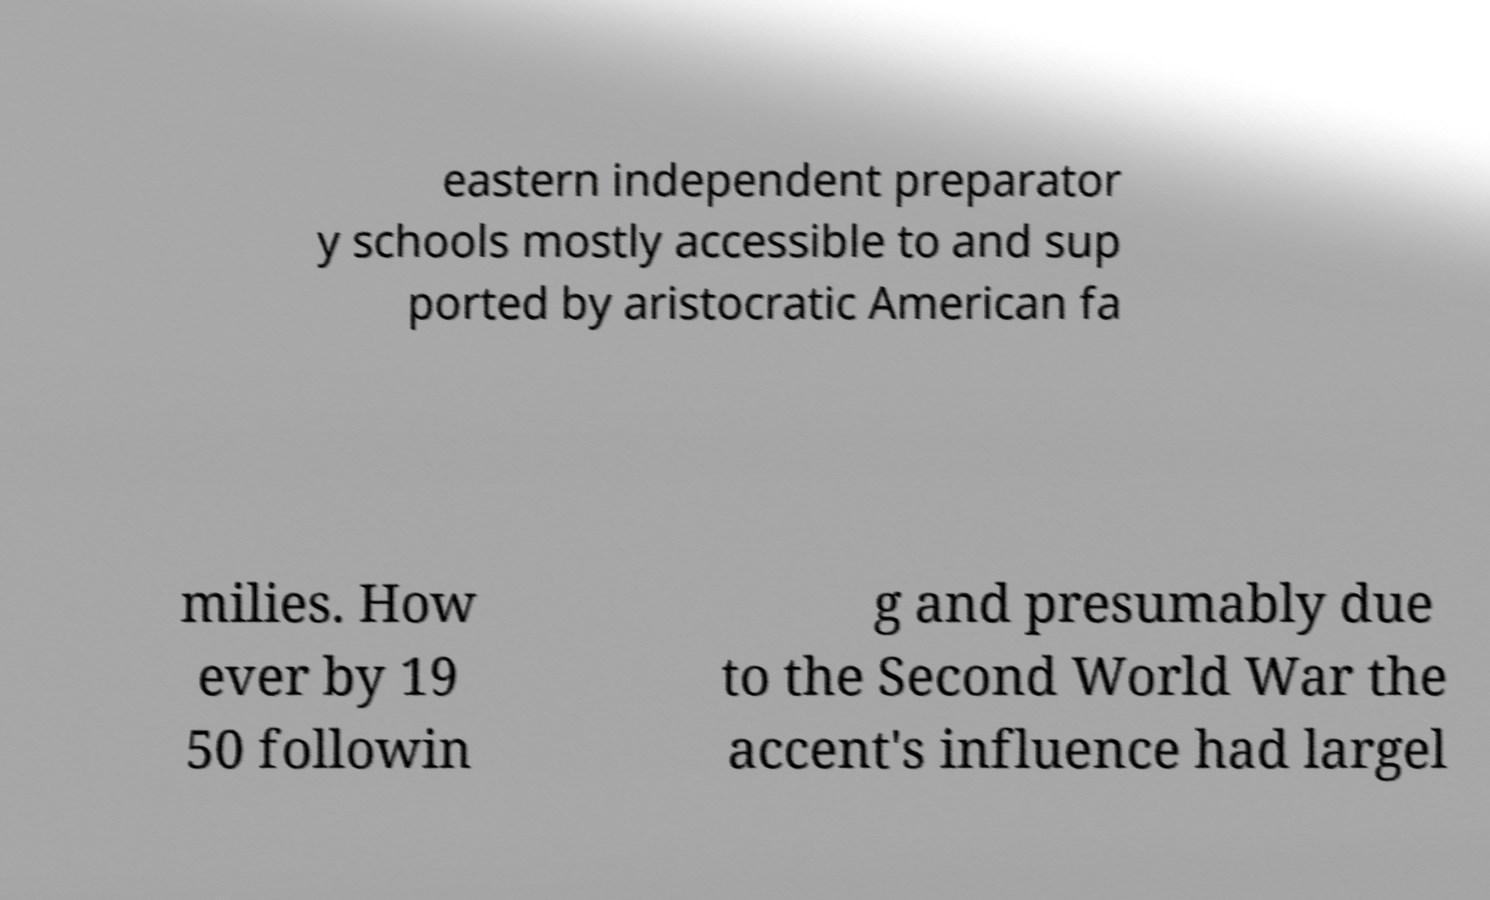For documentation purposes, I need the text within this image transcribed. Could you provide that? eastern independent preparator y schools mostly accessible to and sup ported by aristocratic American fa milies. How ever by 19 50 followin g and presumably due to the Second World War the accent's influence had largel 